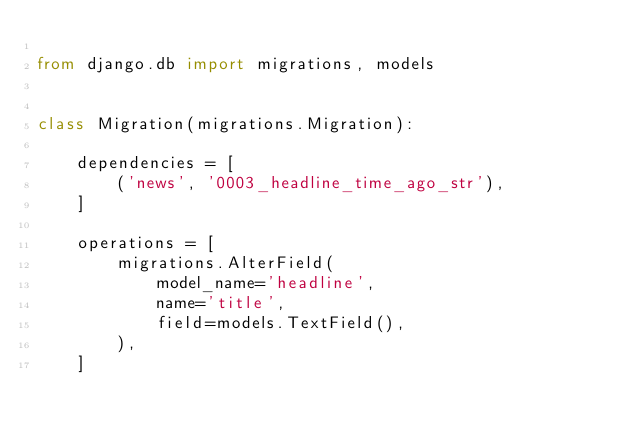Convert code to text. <code><loc_0><loc_0><loc_500><loc_500><_Python_>
from django.db import migrations, models


class Migration(migrations.Migration):

    dependencies = [
        ('news', '0003_headline_time_ago_str'),
    ]

    operations = [
        migrations.AlterField(
            model_name='headline',
            name='title',
            field=models.TextField(),
        ),
    ]
</code> 